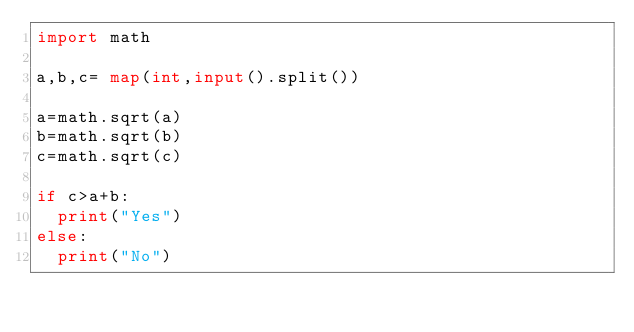<code> <loc_0><loc_0><loc_500><loc_500><_Python_>import math

a,b,c= map(int,input().split())

a=math.sqrt(a)
b=math.sqrt(b)
c=math.sqrt(c)

if c>a+b:
  print("Yes")
else:
  print("No")</code> 